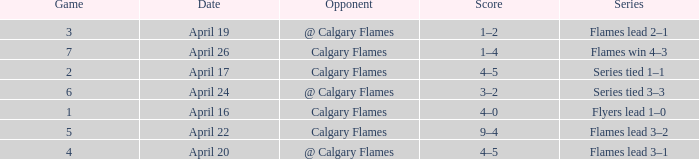Which Series has a Score of 9–4? Flames lead 3–2. 